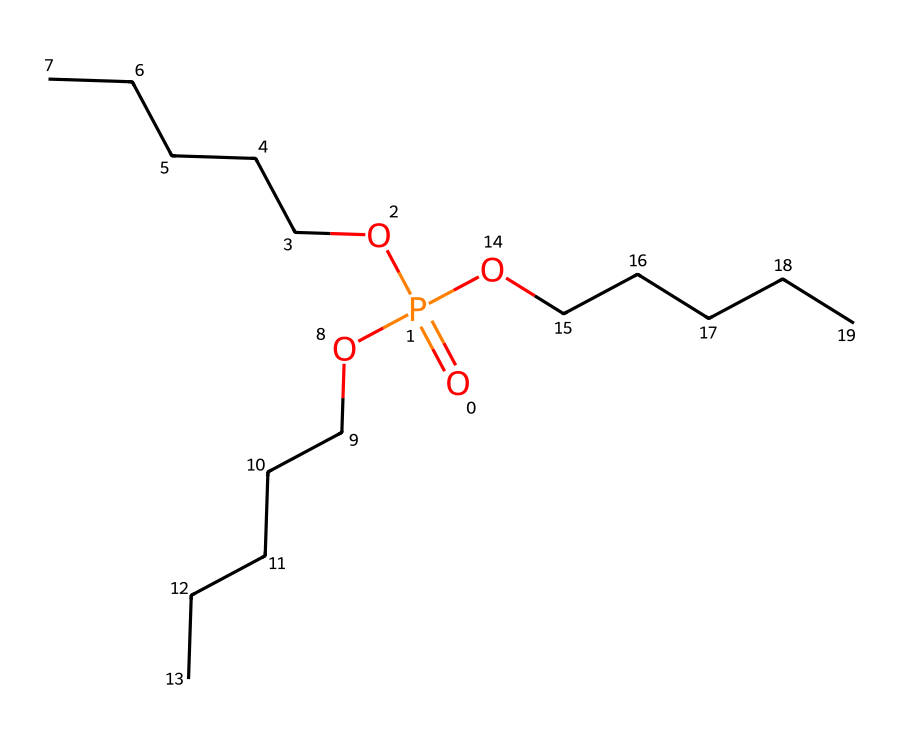What is the central atom in this compound? The chemical structure shows that phosphorus (P) is the central atom surrounded by oxygen and carbon chains.
Answer: phosphorus How many ethyl groups are attached to the phosphorus? By observing the structure, there are three ethyl groups (OCCCCC) bonded to the phosphorus atom.
Answer: three What is the oxidation state of phosphorus in this compound? In this case, the phosphorus is bonded to four oxygen atoms, two of which are in the phosphate diester form, indicating an oxidation state of +5.
Answer: +5 What functional groups are present in this molecule? The molecule includes phosphate groups, as indicated by the presence of the phosphorus atom bonded to multiple oxygen atoms and the ethyl chains.
Answer: phosphate What type of chemical bond predominates in this structure? Analyzing the connections between phosphorus, oxygen, and carbon shows that there are covalent bonds throughout the compound.
Answer: covalent What property would make this compound useful as a flame retardant? The presence of phosphorus, which is known for its ability to form char during combustion, contributes to its flame-retardant properties.
Answer: flame-retardant properties 